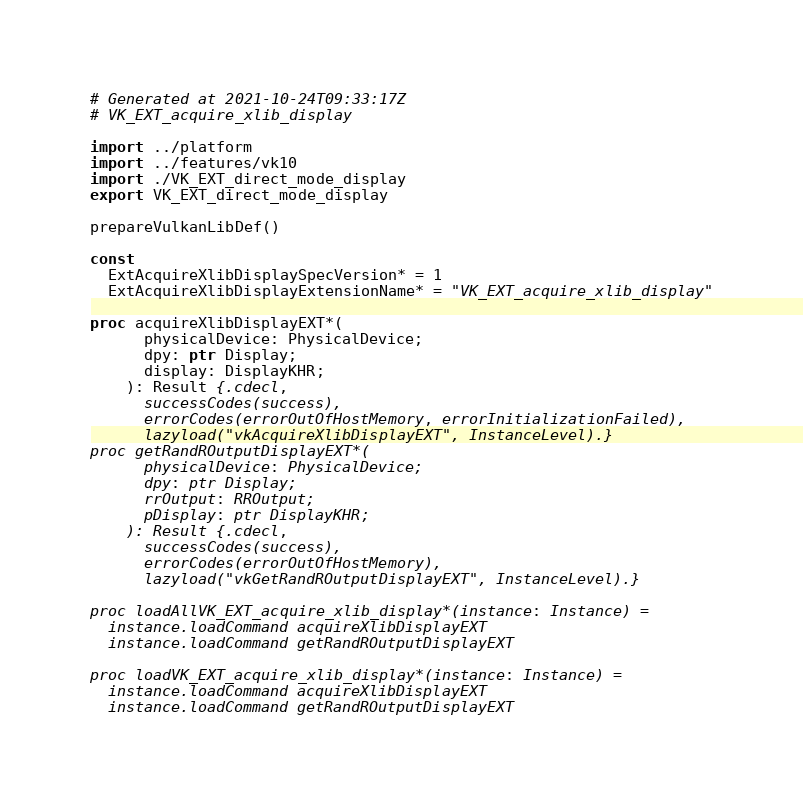Convert code to text. <code><loc_0><loc_0><loc_500><loc_500><_Nim_># Generated at 2021-10-24T09:33:17Z
# VK_EXT_acquire_xlib_display

import ../platform
import ../features/vk10
import ./VK_EXT_direct_mode_display
export VK_EXT_direct_mode_display

prepareVulkanLibDef()

const
  ExtAcquireXlibDisplaySpecVersion* = 1
  ExtAcquireXlibDisplayExtensionName* = "VK_EXT_acquire_xlib_display"

proc acquireXlibDisplayEXT*(
      physicalDevice: PhysicalDevice;
      dpy: ptr Display;
      display: DisplayKHR;
    ): Result {.cdecl,
      successCodes(success),
      errorCodes(errorOutOfHostMemory, errorInitializationFailed),
      lazyload("vkAcquireXlibDisplayEXT", InstanceLevel).}
proc getRandROutputDisplayEXT*(
      physicalDevice: PhysicalDevice;
      dpy: ptr Display;
      rrOutput: RROutput;
      pDisplay: ptr DisplayKHR;
    ): Result {.cdecl,
      successCodes(success),
      errorCodes(errorOutOfHostMemory),
      lazyload("vkGetRandROutputDisplayEXT", InstanceLevel).}

proc loadAllVK_EXT_acquire_xlib_display*(instance: Instance) =
  instance.loadCommand acquireXlibDisplayEXT
  instance.loadCommand getRandROutputDisplayEXT

proc loadVK_EXT_acquire_xlib_display*(instance: Instance) =
  instance.loadCommand acquireXlibDisplayEXT
  instance.loadCommand getRandROutputDisplayEXT

</code> 